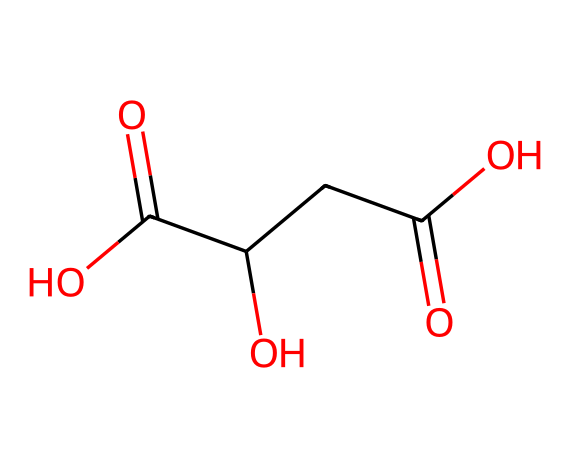How many carbon atoms are in malic acid? The SMILES representation reveals four carbon atoms present in the structure, indicated by the four 'C' symbols.
Answer: four What functional groups are present in malic acid? The structure includes two carboxylic acid groups (-COOH) and one hydroxyl group (-OH), identifiable by the presence of these groups in the SMILES representation.
Answer: carboxylic acid and hydroxyl What is the molecular formula of malic acid? By analyzing the SMILES, we can count the atoms: 4 carbons, 6 hydrogens, and 4 oxygens, leading to the molecular formula C4H6O5.
Answer: C4H6O5 How many total oxygen atoms are present in malic acid? The chemical structure indicates five oxygen atoms, as counted from the part of the structure showing -COOH and the -C(=O)O groups.
Answer: five What is the acidic nature of malic acid attributed to? Malic acid has two carboxylic acid groups (-COOH) that can donate protons (H+), making it an acid and contributing to its acidity.
Answer: carboxylic acid groups What type of acid is malic acid? Malic acid is categorized as a dicarboxylic acid because it has two carboxylic acid groups in its structure.
Answer: dicarboxylic acid What role does malic acid play in apples? In apples, malic acid contributes to the tart taste and is also involved in the fruit's metabolism and preservation.
Answer: tartness 